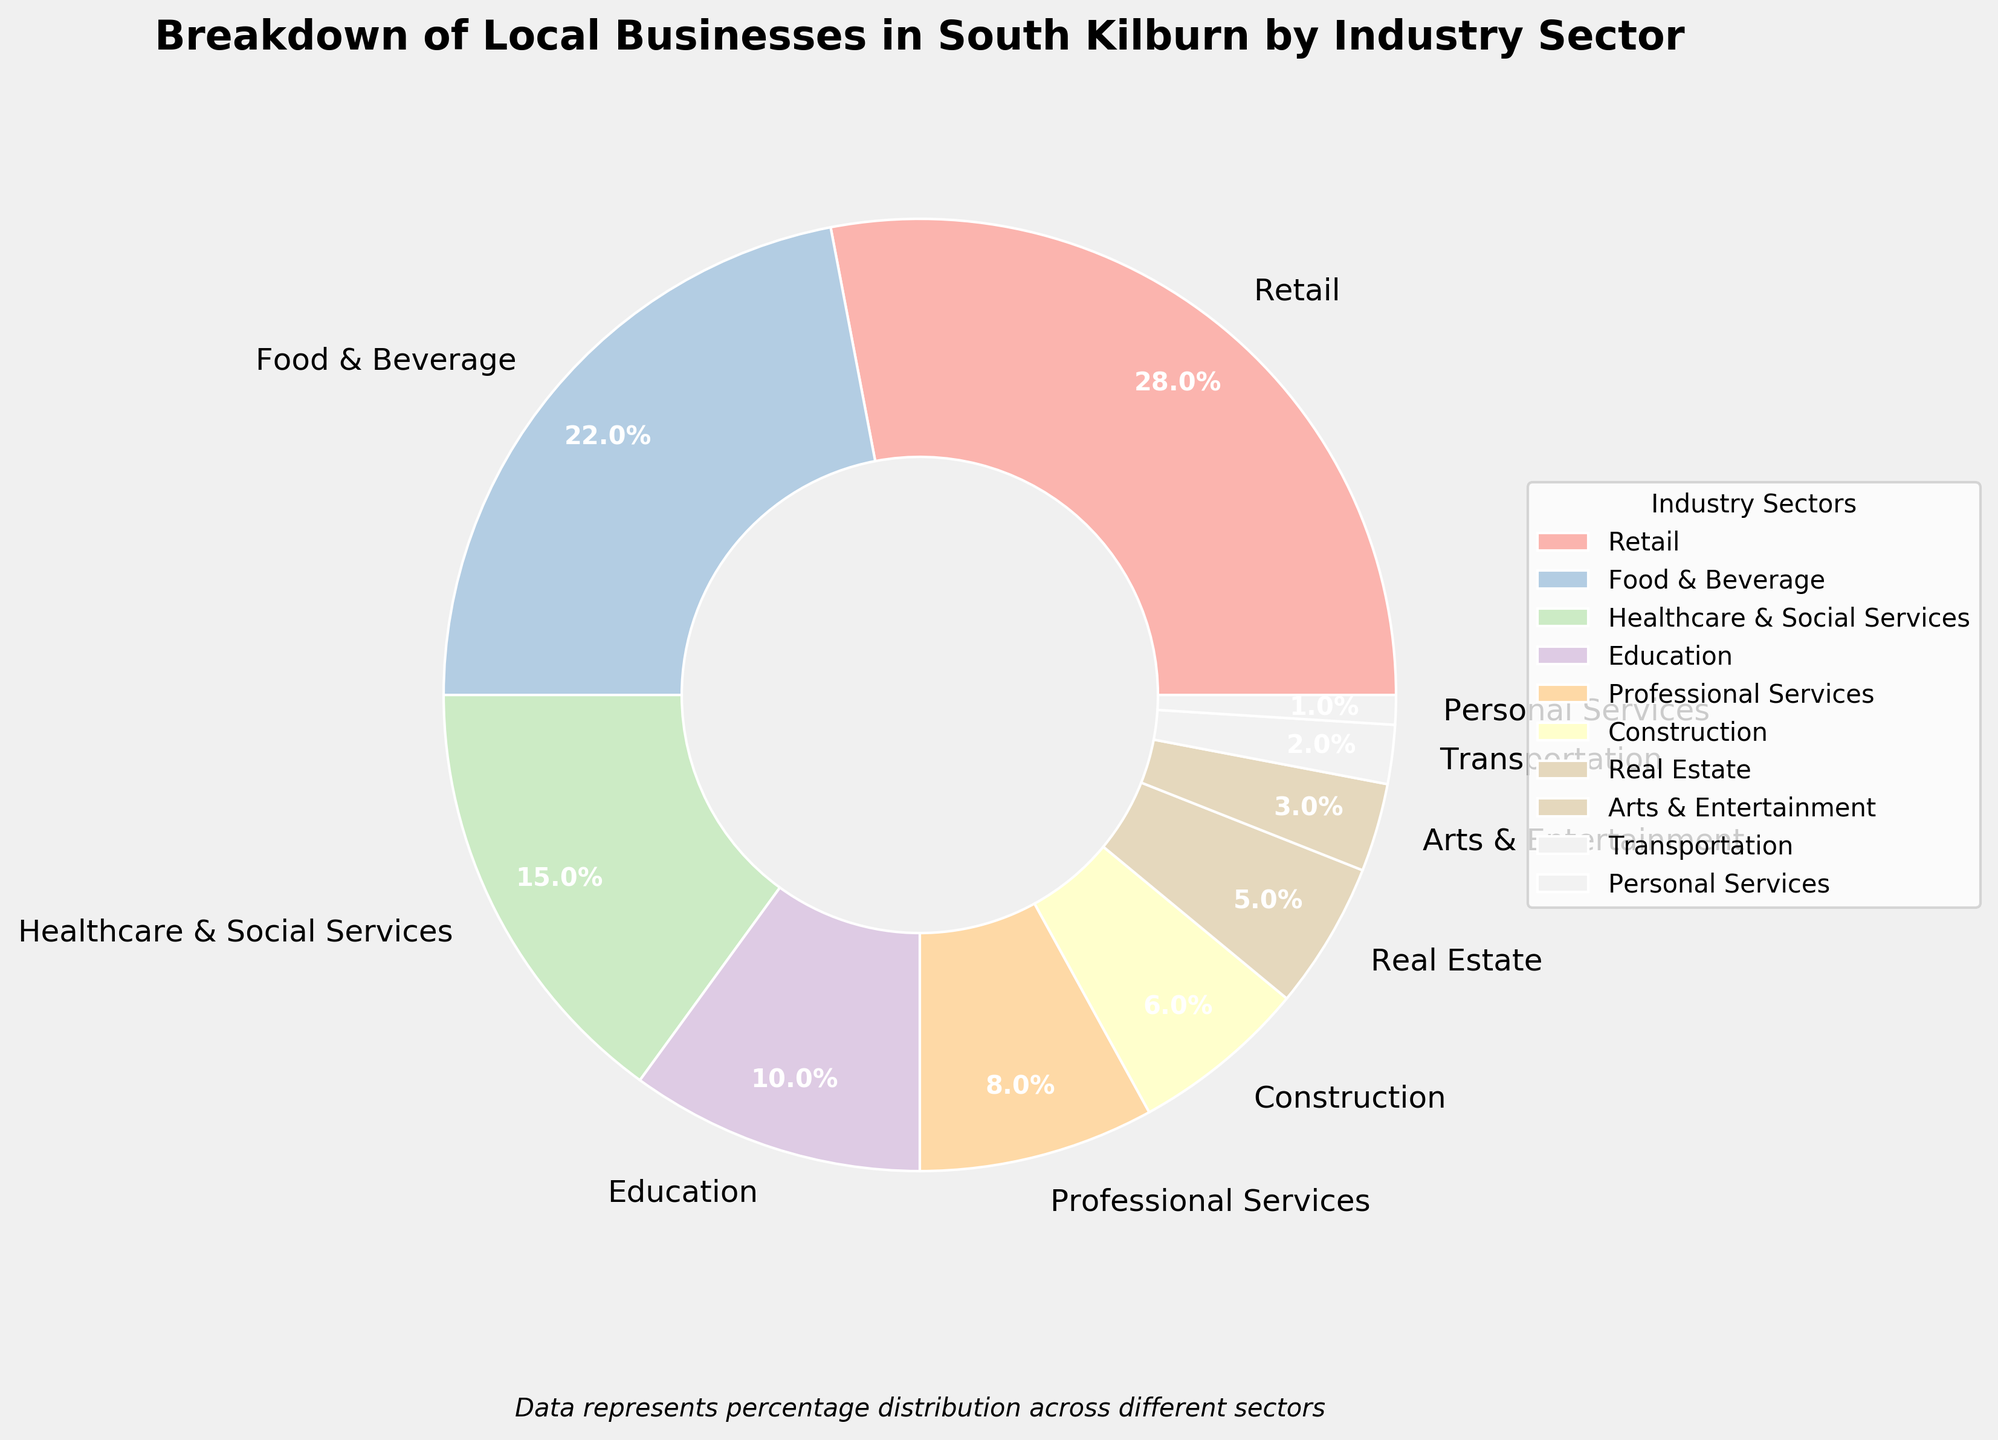Which industry sector has the highest percentage of local businesses? By examining the pie chart, you can see that the sector with the largest slice is the one with the highest percentage of local businesses.
Answer: Retail Which two industry sectors combined have the same percentage as the Food & Beverage sector? The Food & Beverage sector has a percentage of 22%. By checking the chart, you can see that the Construction sector (6%) and the Education sector (10%) combined give 16%, which is less. So, consider Healthcare & Social Services (15%) and Real Estate (5%) which make 20%. This is closer, but check Retail (28%) minus 6% (Construction), it gives 22%. Finally, Professional Services (8%) and Healthcare & Social Services (15%) combined make 23%. Thus, the exact sectors do need careful matching like 15 + 5 for example of sectors and combinations.
Answer: Healthcare & Social Services + Real Estate Which sector has the smallest percentage of local businesses? By looking at the slices and the legend, you can identify the smallest slice, which represents the sector with the smallest percentage.
Answer: Personal Services What is the difference in percentage points between the Retail sector and the Professional Services sector? The Retail sector has 28% and the Professional Services sector has 8%. Subtract 8 from 28.
Answer: 20 How do the combined percentages of the Arts & Entertainment and Transportation sectors compare to the Healthcare & Social Services sector? The Arts & Entertainment sector is 3% and Transportation is 2%, combined total is 5%. Healthcare & Social Services is 15%, so compare 5% to 15%.
Answer: Less than Are there more local businesses in Professional Services or in Education? Check the pie chart percentages: Professional Services (8%) is less than Education (10%).
Answer: Education What is the total percentage of local businesses in the Retail, Food & Beverage, and Healthcare & Social Services sectors combined? Add the percentages of Retail (28%), Food & Beverage (22%), and Healthcare & Social Services (15%): 28 + 22 + 15 = 65.
Answer: 65 Which sector is represented by a wedge with a white edge color and is located next to Retail in the figure? Observe the visual layout where Retail is in the chart, and identify the wedge next to it. This depends on the arrangement so assume Food & Beverage (if clockwise) - Confirm by visual check.
Answer: Food & Beverage How many sectors have a percentage less than 5%? Look at the pie chart segments and count those with percentages less than 5%.
Answer: Three (Arts & Entertainment, Transportation, Personal Services) Is the percentage of Real Estate businesses higher or lower than the Construction sector? Compare the slices: Real Estate (5%) is lower than Construction (6%).
Answer: Lower 